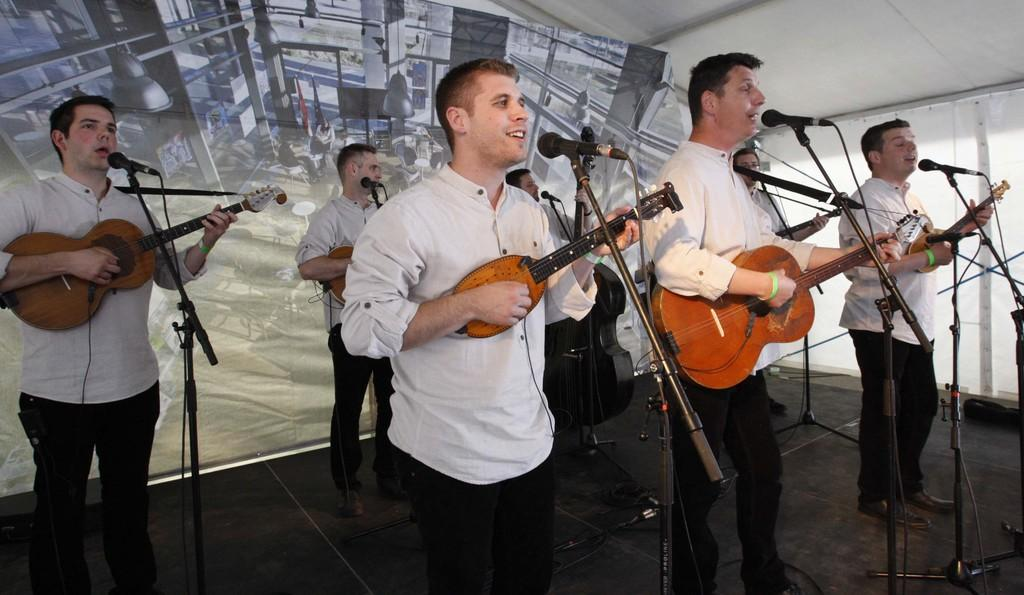What is happening in the image involving a group of people? In the image, there is a group of people standing and holding guitars. What are the people doing with their guitars? The people are playing their guitars while singing a song. How are the people amplifying their voices in the image? The people are using microphones to amplify their voices. What type of health care is being provided to the goldfish in the image? There is no goldfish present in the image, and therefore no health care is being provided. 